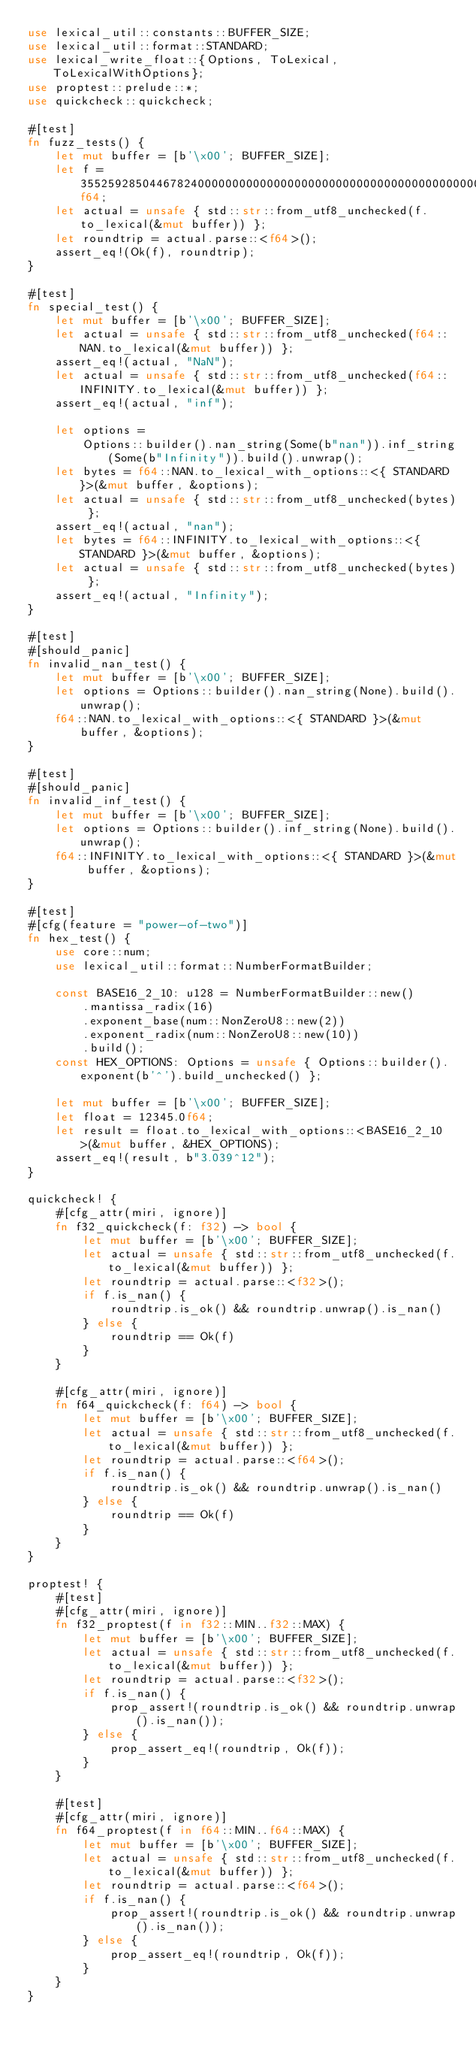<code> <loc_0><loc_0><loc_500><loc_500><_Rust_>use lexical_util::constants::BUFFER_SIZE;
use lexical_util::format::STANDARD;
use lexical_write_float::{Options, ToLexical, ToLexicalWithOptions};
use proptest::prelude::*;
use quickcheck::quickcheck;

#[test]
fn fuzz_tests() {
    let mut buffer = [b'\x00'; BUFFER_SIZE];
    let f = 355259285044678240000000000000000000000000000000000000000000f64;
    let actual = unsafe { std::str::from_utf8_unchecked(f.to_lexical(&mut buffer)) };
    let roundtrip = actual.parse::<f64>();
    assert_eq!(Ok(f), roundtrip);
}

#[test]
fn special_test() {
    let mut buffer = [b'\x00'; BUFFER_SIZE];
    let actual = unsafe { std::str::from_utf8_unchecked(f64::NAN.to_lexical(&mut buffer)) };
    assert_eq!(actual, "NaN");
    let actual = unsafe { std::str::from_utf8_unchecked(f64::INFINITY.to_lexical(&mut buffer)) };
    assert_eq!(actual, "inf");

    let options =
        Options::builder().nan_string(Some(b"nan")).inf_string(Some(b"Infinity")).build().unwrap();
    let bytes = f64::NAN.to_lexical_with_options::<{ STANDARD }>(&mut buffer, &options);
    let actual = unsafe { std::str::from_utf8_unchecked(bytes) };
    assert_eq!(actual, "nan");
    let bytes = f64::INFINITY.to_lexical_with_options::<{ STANDARD }>(&mut buffer, &options);
    let actual = unsafe { std::str::from_utf8_unchecked(bytes) };
    assert_eq!(actual, "Infinity");
}

#[test]
#[should_panic]
fn invalid_nan_test() {
    let mut buffer = [b'\x00'; BUFFER_SIZE];
    let options = Options::builder().nan_string(None).build().unwrap();
    f64::NAN.to_lexical_with_options::<{ STANDARD }>(&mut buffer, &options);
}

#[test]
#[should_panic]
fn invalid_inf_test() {
    let mut buffer = [b'\x00'; BUFFER_SIZE];
    let options = Options::builder().inf_string(None).build().unwrap();
    f64::INFINITY.to_lexical_with_options::<{ STANDARD }>(&mut buffer, &options);
}

#[test]
#[cfg(feature = "power-of-two")]
fn hex_test() {
    use core::num;
    use lexical_util::format::NumberFormatBuilder;

    const BASE16_2_10: u128 = NumberFormatBuilder::new()
        .mantissa_radix(16)
        .exponent_base(num::NonZeroU8::new(2))
        .exponent_radix(num::NonZeroU8::new(10))
        .build();
    const HEX_OPTIONS: Options = unsafe { Options::builder().exponent(b'^').build_unchecked() };

    let mut buffer = [b'\x00'; BUFFER_SIZE];
    let float = 12345.0f64;
    let result = float.to_lexical_with_options::<BASE16_2_10>(&mut buffer, &HEX_OPTIONS);
    assert_eq!(result, b"3.039^12");
}

quickcheck! {
    #[cfg_attr(miri, ignore)]
    fn f32_quickcheck(f: f32) -> bool {
        let mut buffer = [b'\x00'; BUFFER_SIZE];
        let actual = unsafe { std::str::from_utf8_unchecked(f.to_lexical(&mut buffer)) };
        let roundtrip = actual.parse::<f32>();
        if f.is_nan() {
            roundtrip.is_ok() && roundtrip.unwrap().is_nan()
        } else {
            roundtrip == Ok(f)
        }
    }

    #[cfg_attr(miri, ignore)]
    fn f64_quickcheck(f: f64) -> bool {
        let mut buffer = [b'\x00'; BUFFER_SIZE];
        let actual = unsafe { std::str::from_utf8_unchecked(f.to_lexical(&mut buffer)) };
        let roundtrip = actual.parse::<f64>();
        if f.is_nan() {
            roundtrip.is_ok() && roundtrip.unwrap().is_nan()
        } else {
            roundtrip == Ok(f)
        }
    }
}

proptest! {
    #[test]
    #[cfg_attr(miri, ignore)]
    fn f32_proptest(f in f32::MIN..f32::MAX) {
        let mut buffer = [b'\x00'; BUFFER_SIZE];
        let actual = unsafe { std::str::from_utf8_unchecked(f.to_lexical(&mut buffer)) };
        let roundtrip = actual.parse::<f32>();
        if f.is_nan() {
            prop_assert!(roundtrip.is_ok() && roundtrip.unwrap().is_nan());
        } else {
            prop_assert_eq!(roundtrip, Ok(f));
        }
    }

    #[test]
    #[cfg_attr(miri, ignore)]
    fn f64_proptest(f in f64::MIN..f64::MAX) {
        let mut buffer = [b'\x00'; BUFFER_SIZE];
        let actual = unsafe { std::str::from_utf8_unchecked(f.to_lexical(&mut buffer)) };
        let roundtrip = actual.parse::<f64>();
        if f.is_nan() {
            prop_assert!(roundtrip.is_ok() && roundtrip.unwrap().is_nan());
        } else {
            prop_assert_eq!(roundtrip, Ok(f));
        }
    }
}
</code> 